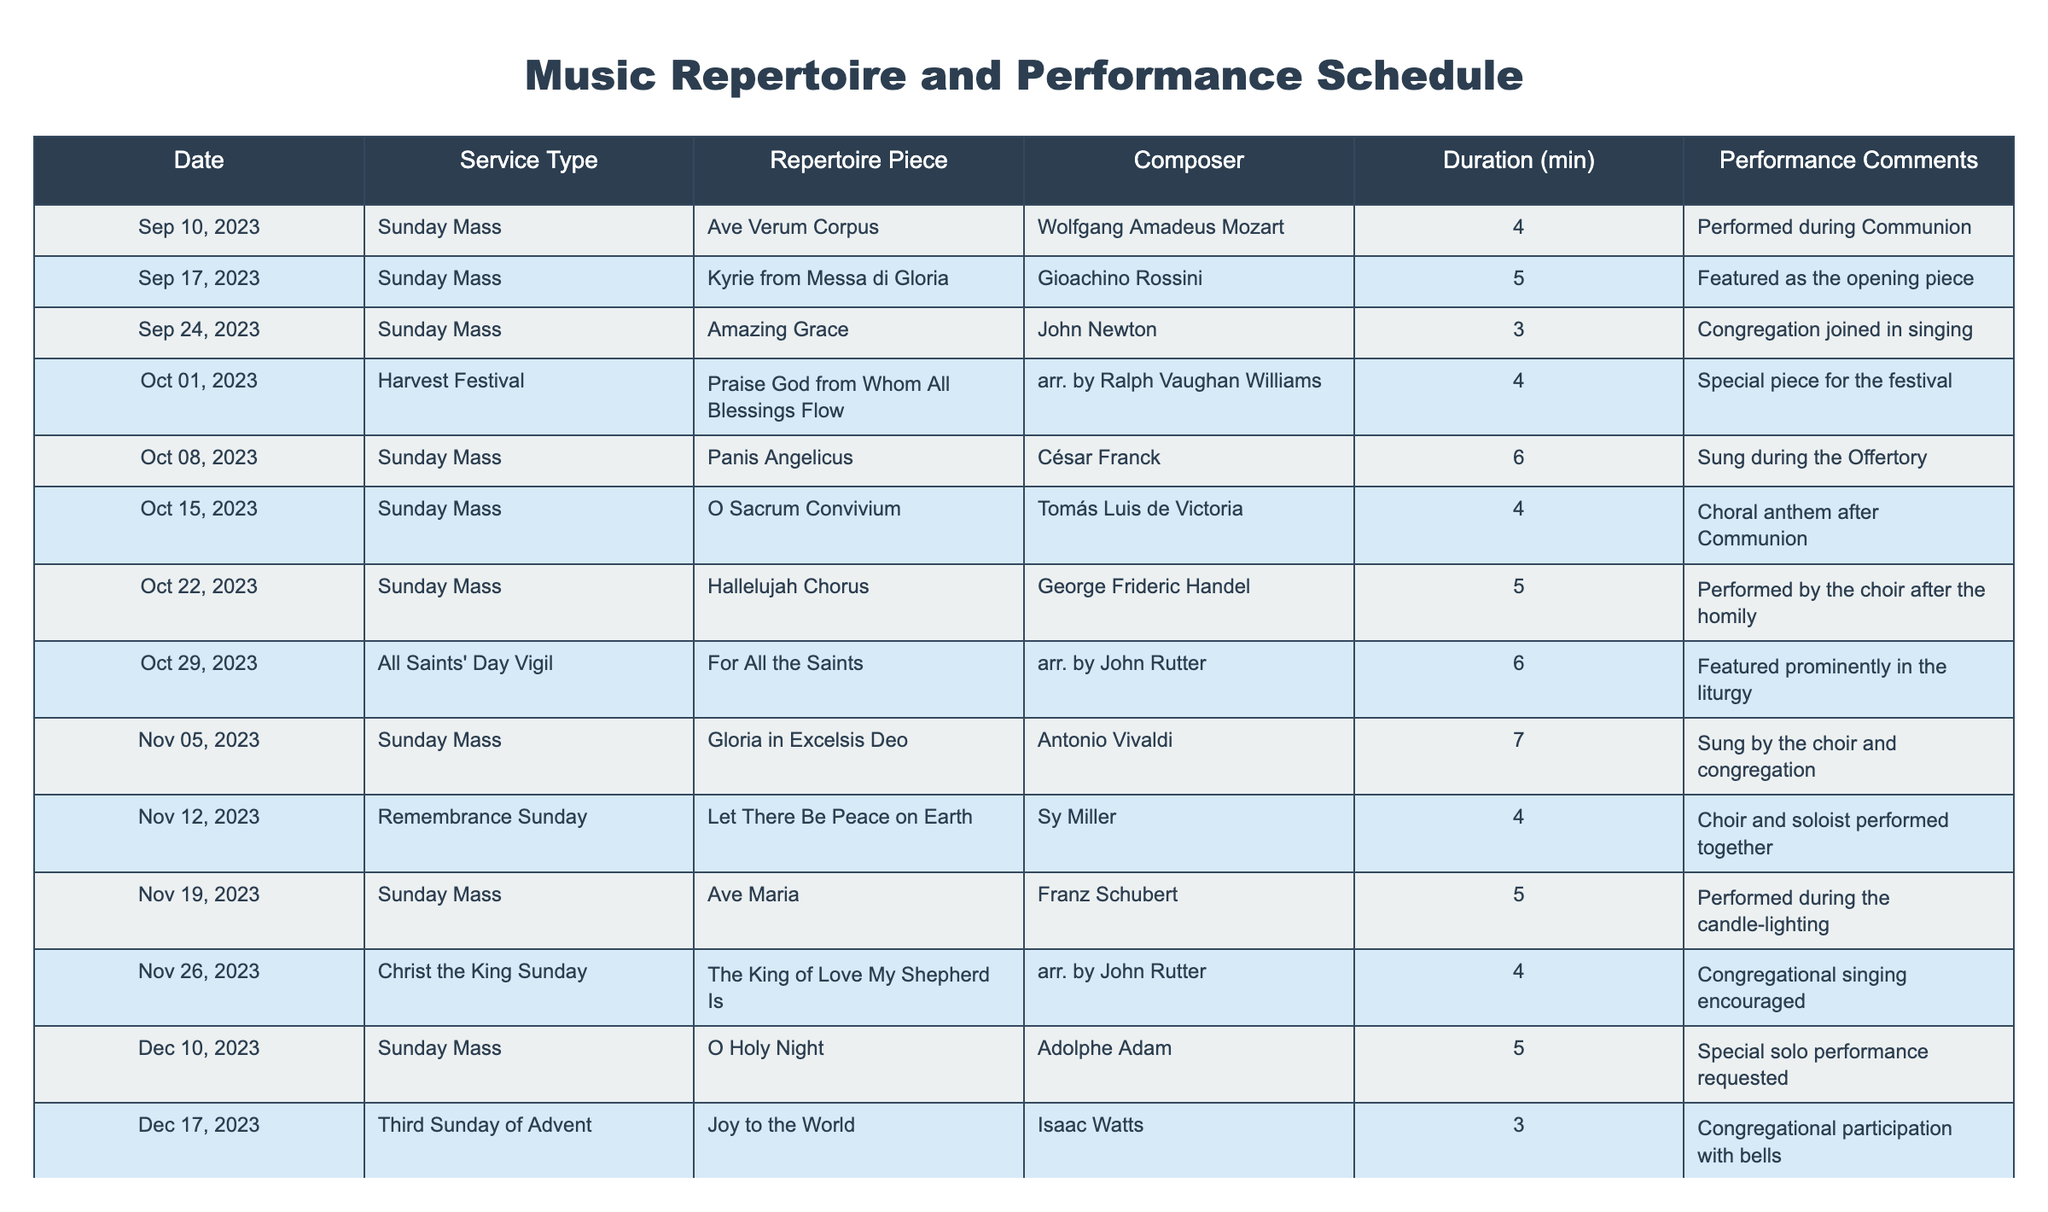What piece was performed during Communion on September 10, 2023? The table shows that "Ave Verum Corpus" by Mozart was performed during Communion on that date.
Answer: "Ave Verum Corpus" Which repertoire piece had the longest duration in the schedule? Reviewing the durations, "Gloria in Excelsis Deo" by Vivaldi is listed as having a duration of 7 minutes, which is the longest among the pieces.
Answer: "Gloria in Excelsis Deo" Did the choir perform "Silent Night" before or after Christmas Day in 2023? According to the table, "Silent Night" was performed on December 24, 2023, which is before Christmas Day (December 25).
Answer: Before What is the total duration of the pieces performed during all Sunday Masses? Adding the durations of the pieces performed during Sunday Masses (4 + 5 + 3 + 6 + 4 + 4 + 5 + 7 + 4 + 5 + 4 + 3 = 57 minutes) gives a total duration of 57 minutes.
Answer: 57 minutes Which composer had the most pieces performed in the schedule? By analyzing the list, both John Rutter and Franz Schubert had two pieces each, more than any other composer.
Answer: John Rutter and Franz Schubert Was "Let There Be Peace on Earth" performed on a Sunday Mass? The table indicates that "Let There Be Peace on Earth" was performed on Remembrance Sunday, which falls on a Sunday.
Answer: Yes How many repertoire pieces were performed during the Harvest Festival? There was one piece performed during the Harvest Festival, which is "Praise God from Whom All Blessings Flow."
Answer: 1 What percentage of the pieces performed were by composers from the Baroque period (like Vivaldi or Handel)? The table lists a total of 15 pieces, with 3 by Baroque composers (Vivaldi, Handel, and Bach), so the percentage is (3/15) * 100 = 20%.
Answer: 20% Which piece received special comments related to candle-lighting? "Ave Maria" by Schubert is noted for being performed during the candle-lighting.
Answer: "Ave Maria" What is the average duration of the pieces from All Saints' Day Vigil to Christmas Day? Adding the durations from that range (6 + 7 + 4 + 4 = 21), we have 4 pieces, so the average duration is 21 / 4 = 5.25 minutes.
Answer: 5.25 minutes 